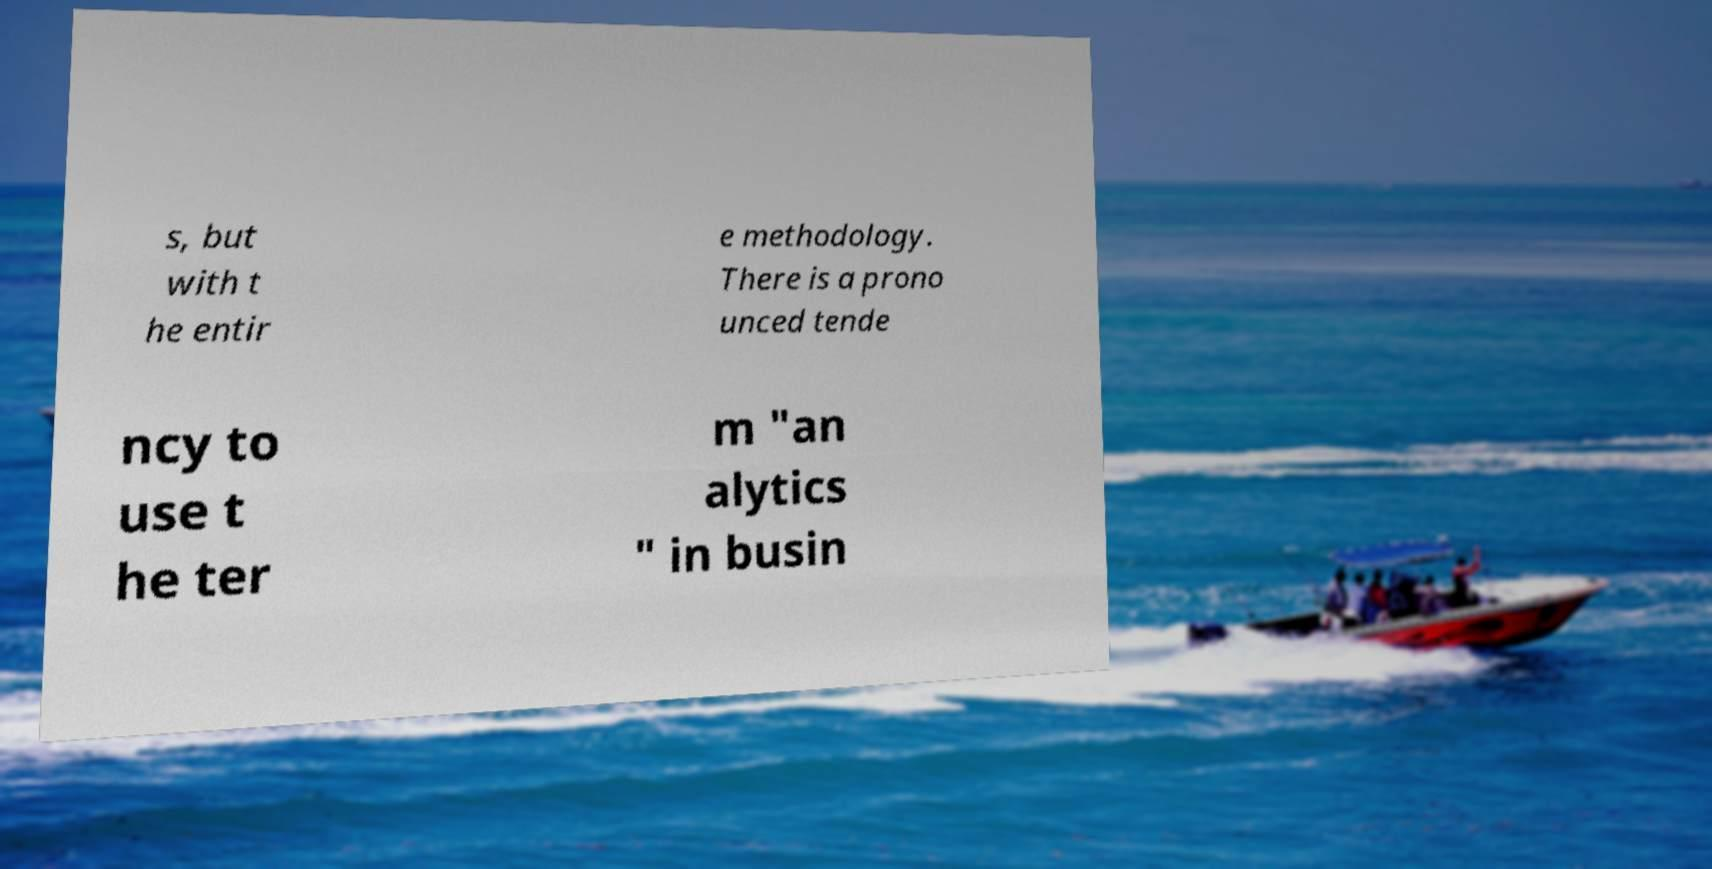Could you extract and type out the text from this image? s, but with t he entir e methodology. There is a prono unced tende ncy to use t he ter m "an alytics " in busin 